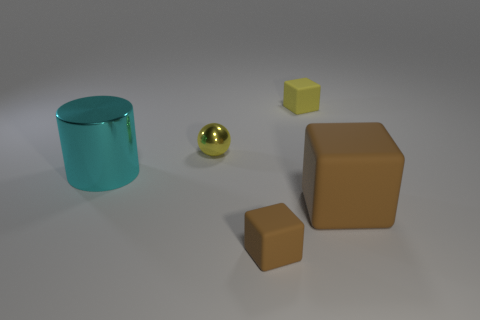Add 5 green shiny balls. How many objects exist? 10 Subtract all blocks. How many objects are left? 2 Subtract 0 blue blocks. How many objects are left? 5 Subtract all cubes. Subtract all blue objects. How many objects are left? 2 Add 5 small metallic objects. How many small metallic objects are left? 6 Add 5 tiny yellow rubber blocks. How many tiny yellow rubber blocks exist? 6 